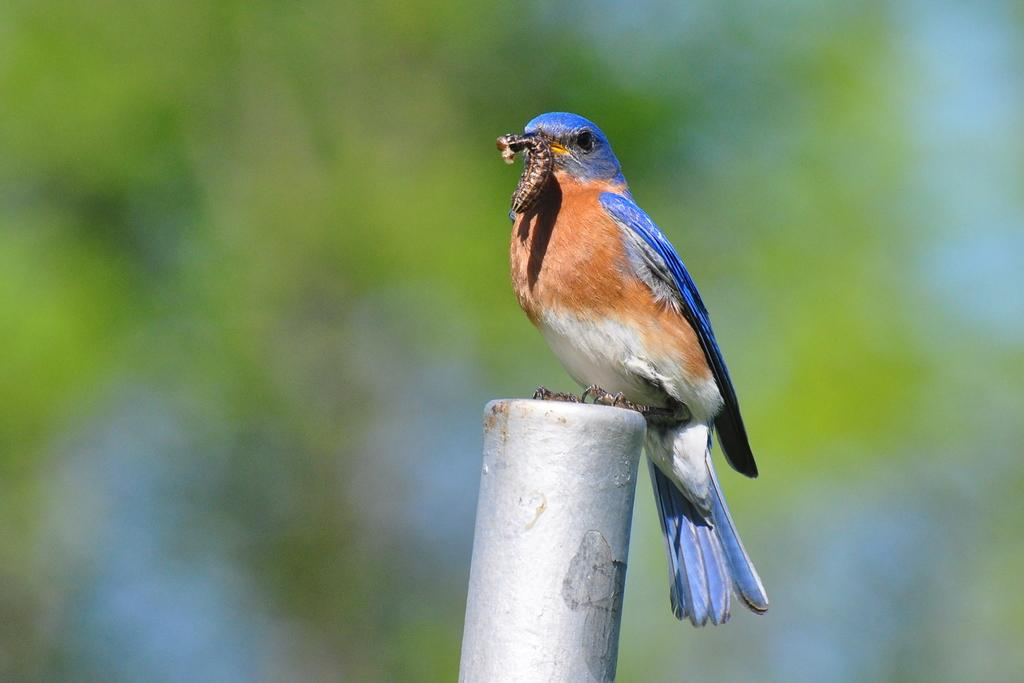What is the main object in the image? There is a white color pole in the image. What is on the pole? A bird is perched on the pole. What is the bird doing? The bird has something in its mouth. Can you describe the background of the image? The background of the image is blurred. What type of apparel is the bird wearing in the image? There is no apparel visible on the bird in the image. How many planes can be seen flying in the background of the image? There are no planes visible in the image; the background is blurred. 